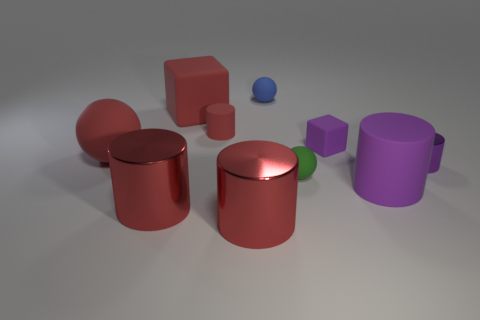There is a matte cylinder that is left of the small green ball; are there any tiny matte things to the left of it?
Offer a terse response. No. What number of purple things are the same material as the big purple cylinder?
Your response must be concise. 1. What size is the matte thing on the right side of the block in front of the big red matte thing on the right side of the big matte sphere?
Provide a short and direct response. Large. There is a blue sphere; how many metal objects are behind it?
Ensure brevity in your answer.  0. Is the number of large matte balls greater than the number of tiny rubber balls?
Keep it short and to the point. No. What size is the ball that is the same color as the big matte block?
Your answer should be compact. Large. How big is the cylinder that is behind the small green object and to the left of the tiny metallic thing?
Give a very brief answer. Small. What is the small green ball that is right of the red cylinder behind the purple matte thing in front of the purple rubber cube made of?
Make the answer very short. Rubber. What material is the large thing that is the same color as the small block?
Provide a succinct answer. Rubber. There is a sphere that is left of the blue object; is its color the same as the big rubber thing in front of the big matte ball?
Provide a short and direct response. No. 